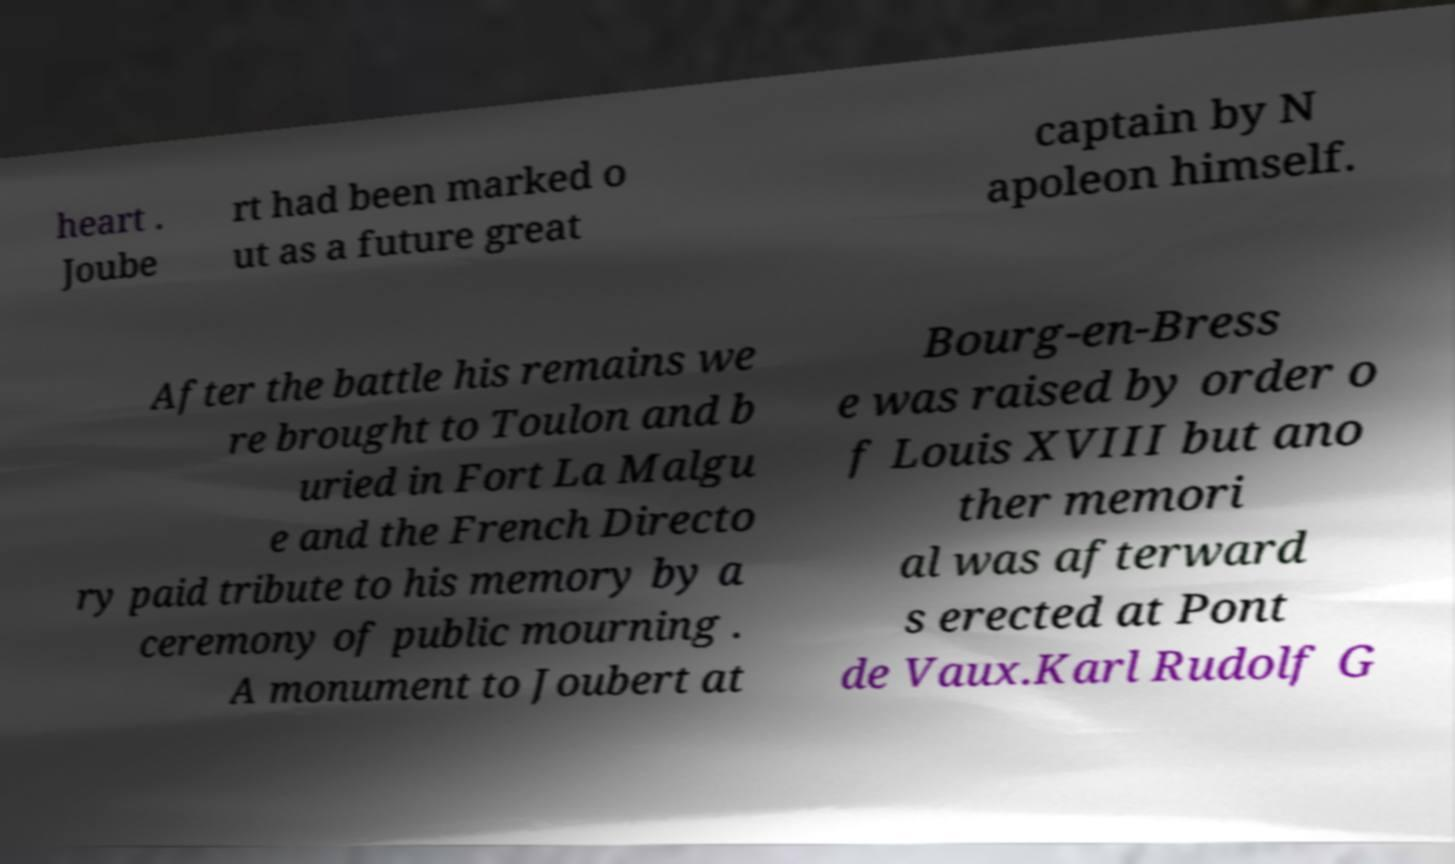Could you assist in decoding the text presented in this image and type it out clearly? heart . Joube rt had been marked o ut as a future great captain by N apoleon himself. After the battle his remains we re brought to Toulon and b uried in Fort La Malgu e and the French Directo ry paid tribute to his memory by a ceremony of public mourning . A monument to Joubert at Bourg-en-Bress e was raised by order o f Louis XVIII but ano ther memori al was afterward s erected at Pont de Vaux.Karl Rudolf G 